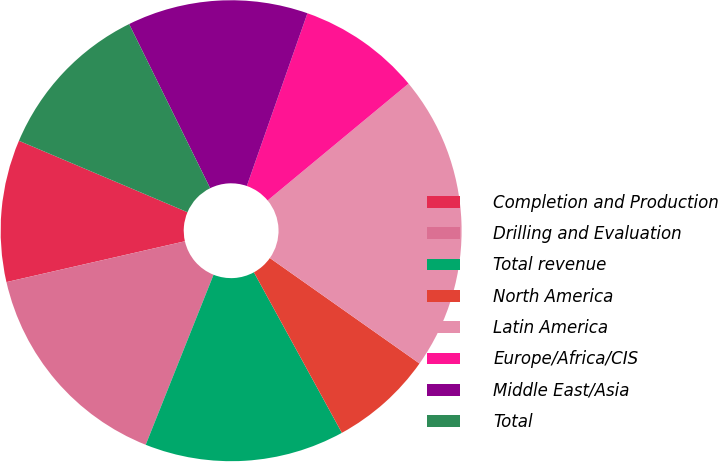Convert chart. <chart><loc_0><loc_0><loc_500><loc_500><pie_chart><fcel>Completion and Production<fcel>Drilling and Evaluation<fcel>Total revenue<fcel>North America<fcel>Latin America<fcel>Europe/Africa/CIS<fcel>Middle East/Asia<fcel>Total<nl><fcel>9.96%<fcel>15.38%<fcel>14.02%<fcel>7.25%<fcel>20.79%<fcel>8.61%<fcel>12.67%<fcel>11.32%<nl></chart> 